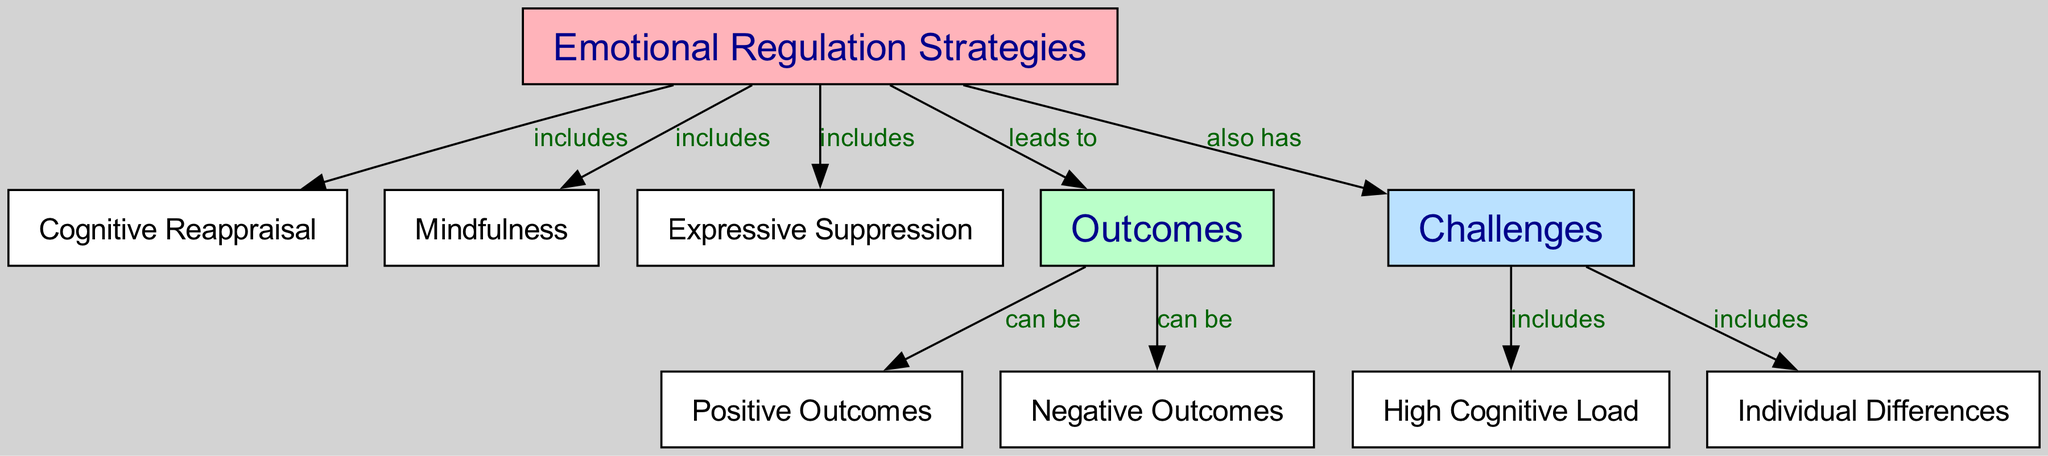What are the three strategies included under Emotional Regulation Strategies? The diagram lists three specific strategies under the node "Emotional Regulation Strategies," which are "Cognitive Reappraisal," "Mindfulness," and "Expressive Suppression."
Answer: Cognitive Reappraisal, Mindfulness, Expressive Suppression How many outcomes can Emotional Regulation Strategies lead to? The diagram shows a single node labeled "Outcomes," which directly connects to two labels below it: "Positive Outcomes" and "Negative Outcomes." This indicates that there are two possibilities for outcomes.
Answer: Two What does Cognitive Reappraisal lead to? According to the connections in the diagram, Cognitive Reappraisal falls under the main strategies and leads directly to the "Outcomes" node, which is a general category. Thus, it contributes to both positive and negative outcomes.
Answer: Outcomes Which challenges are associated with Emotional Regulation Strategies? The diagram specifies a node labeled "Challenges" that connects to two sub-categories beneath it: "High Cognitive Load" and "Individual Differences." This indicates that these are the challenges associated with the strategies.
Answer: High Cognitive Load, Individual Differences What kind of outcomes can the Emotional Regulation Strategies yield? The "Outcomes" node is linked to "Positive Outcomes" and "Negative Outcomes," indicating that the results of applying these strategies can be classified into two categories: positive and negative.
Answer: Positive Outcomes, Negative Outcomes What is an example of a challenge related to individual differences in emotional regulation? Within the node "Challenges," the diagram specifically notes "Individual Differences" as one of the challenges, indicating that individual variability affects the effectiveness of emotional regulation strategies.
Answer: Individual Differences Which strategy is not categorized as an outcome or challenge? By analyzing the diagram, we can see that "Cognitive Reappraisal," "Mindfulness," and "Expressive Suppression" are the three strategies that do not fall under the outcomes or challenges categories; they stem directly from the main strategies node.
Answer: Cognitive Reappraisal, Mindfulness, Expressive Suppression What do challenges like high cognitive load and individual differences represent in the diagram? In the structure of the diagram, both "High Cognitive Load" and "Individual Differences" are branches that fall under the larger node of "Challenges," indicating obstacles that may affect the implementation of emotional regulation strategies.
Answer: Challenges 